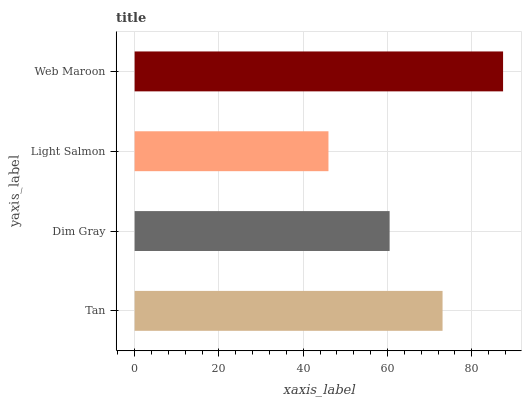Is Light Salmon the minimum?
Answer yes or no. Yes. Is Web Maroon the maximum?
Answer yes or no. Yes. Is Dim Gray the minimum?
Answer yes or no. No. Is Dim Gray the maximum?
Answer yes or no. No. Is Tan greater than Dim Gray?
Answer yes or no. Yes. Is Dim Gray less than Tan?
Answer yes or no. Yes. Is Dim Gray greater than Tan?
Answer yes or no. No. Is Tan less than Dim Gray?
Answer yes or no. No. Is Tan the high median?
Answer yes or no. Yes. Is Dim Gray the low median?
Answer yes or no. Yes. Is Web Maroon the high median?
Answer yes or no. No. Is Tan the low median?
Answer yes or no. No. 